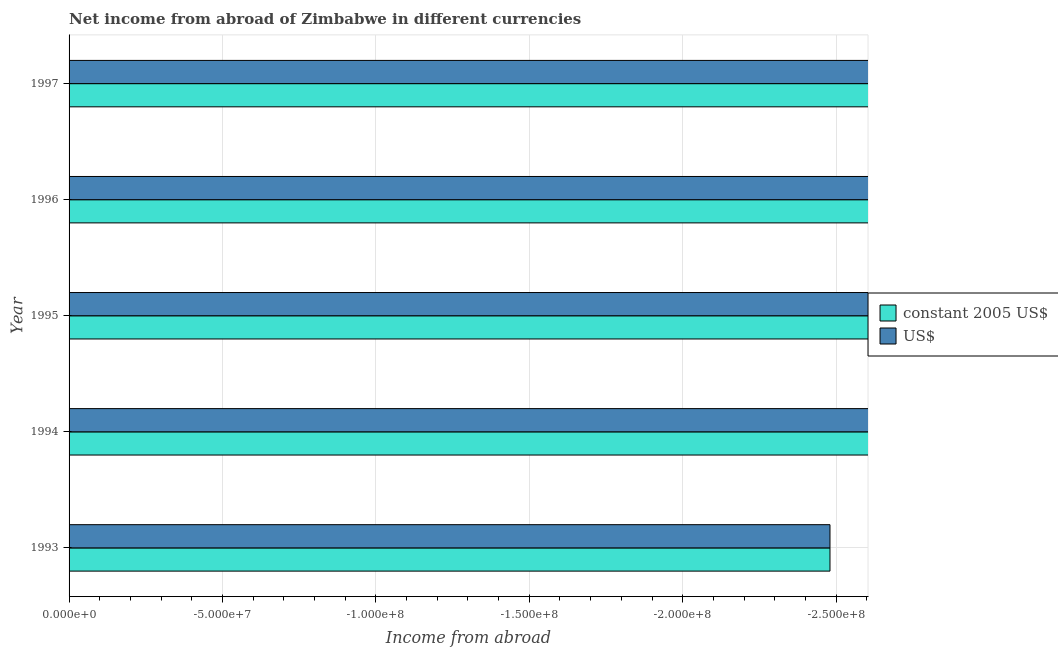Are the number of bars per tick equal to the number of legend labels?
Offer a very short reply. No. Are the number of bars on each tick of the Y-axis equal?
Your response must be concise. Yes. How many bars are there on the 4th tick from the top?
Ensure brevity in your answer.  0. How many bars are there on the 3rd tick from the bottom?
Your answer should be compact. 0. What is the label of the 4th group of bars from the top?
Keep it short and to the point. 1994. In how many cases, is the number of bars for a given year not equal to the number of legend labels?
Provide a succinct answer. 5. What is the total income from abroad in constant 2005 us$ in the graph?
Your response must be concise. 0. In how many years, is the income from abroad in constant 2005 us$ greater than -130000000 units?
Keep it short and to the point. 0. In how many years, is the income from abroad in constant 2005 us$ greater than the average income from abroad in constant 2005 us$ taken over all years?
Provide a short and direct response. 0. How many bars are there?
Make the answer very short. 0. Are all the bars in the graph horizontal?
Provide a short and direct response. Yes. Are the values on the major ticks of X-axis written in scientific E-notation?
Provide a short and direct response. Yes. Does the graph contain grids?
Make the answer very short. Yes. Where does the legend appear in the graph?
Provide a succinct answer. Center right. How are the legend labels stacked?
Your answer should be compact. Vertical. What is the title of the graph?
Offer a terse response. Net income from abroad of Zimbabwe in different currencies. Does "Largest city" appear as one of the legend labels in the graph?
Give a very brief answer. No. What is the label or title of the X-axis?
Your answer should be very brief. Income from abroad. What is the label or title of the Y-axis?
Offer a very short reply. Year. What is the Income from abroad in constant 2005 US$ in 1995?
Your answer should be very brief. 0. What is the Income from abroad of US$ in 1995?
Offer a very short reply. 0. What is the Income from abroad in constant 2005 US$ in 1996?
Ensure brevity in your answer.  0. What is the Income from abroad of constant 2005 US$ in 1997?
Offer a very short reply. 0. What is the total Income from abroad of constant 2005 US$ in the graph?
Provide a succinct answer. 0. What is the total Income from abroad in US$ in the graph?
Offer a terse response. 0. What is the average Income from abroad of constant 2005 US$ per year?
Give a very brief answer. 0. 